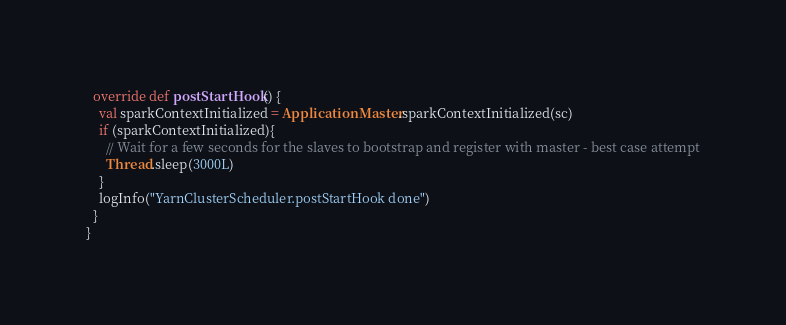Convert code to text. <code><loc_0><loc_0><loc_500><loc_500><_Scala_>  override def postStartHook() {
    val sparkContextInitialized = ApplicationMaster.sparkContextInitialized(sc)
    if (sparkContextInitialized){
      // Wait for a few seconds for the slaves to bootstrap and register with master - best case attempt
      Thread.sleep(3000L)
    }
    logInfo("YarnClusterScheduler.postStartHook done")
  }
}
</code> 